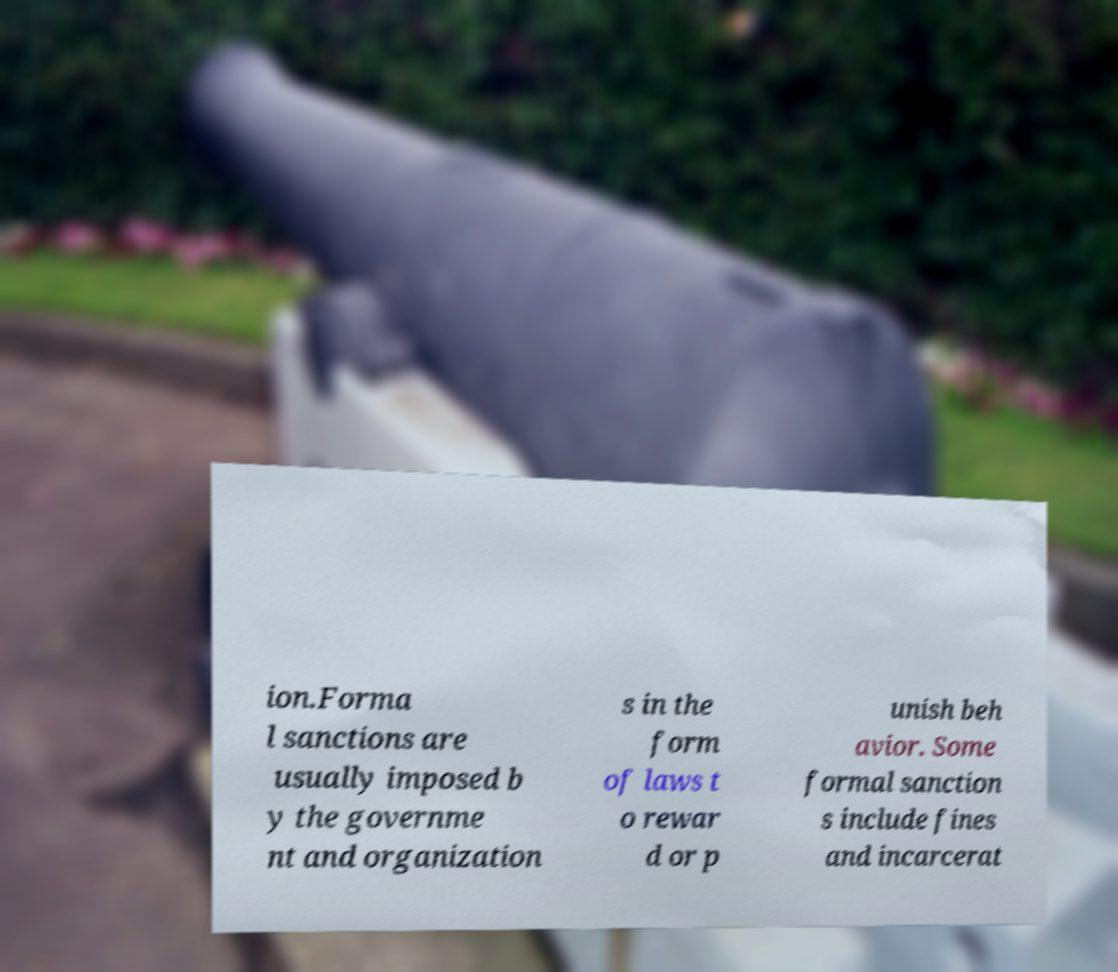Can you accurately transcribe the text from the provided image for me? ion.Forma l sanctions are usually imposed b y the governme nt and organization s in the form of laws t o rewar d or p unish beh avior. Some formal sanction s include fines and incarcerat 